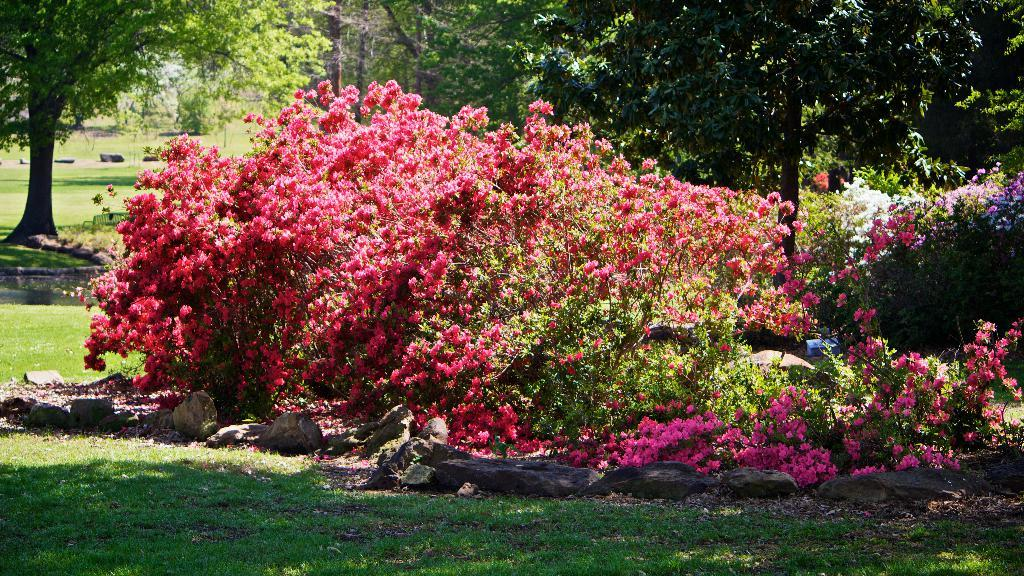What type of vegetation can be seen in the image? There are many trees and flower plants in the image. What else can be found on the ground in the image? There are stones and grass visible in the image. How many lizards can be seen climbing on the trees in the image? There are no lizards present in the image; it only features trees, flower plants, stones, and grass. What type of flower is the hen holding in the image? There is no hen or flower present in the image. 